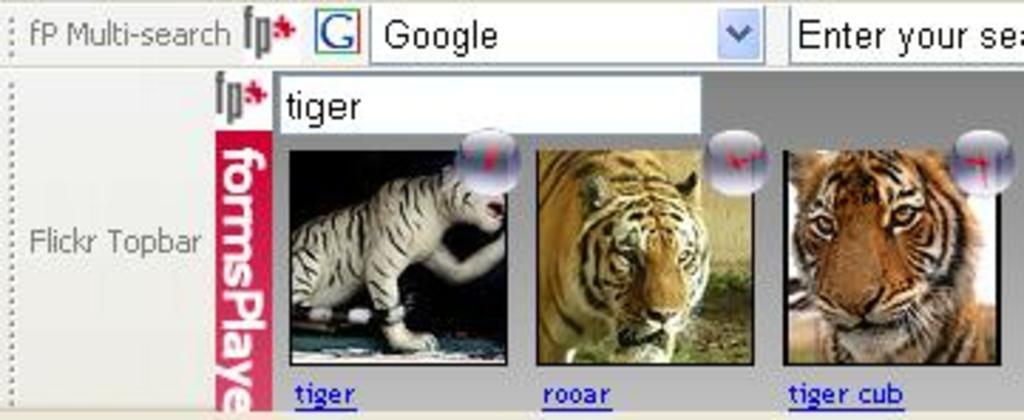What is the main subject of the image? The main subject of the image is a web page. What can be found on the web page? There is text written on the web page. Are there any images on the web page? Yes, there are three pictures of tigers in the image. How many hydrants are visible in the image? There are no hydrants present in the image; it features a web page with text and pictures of tigers. What type of company is represented by the web page in the image? The image does not provide information about a specific company; it only shows a web page with text and pictures of tigers. 